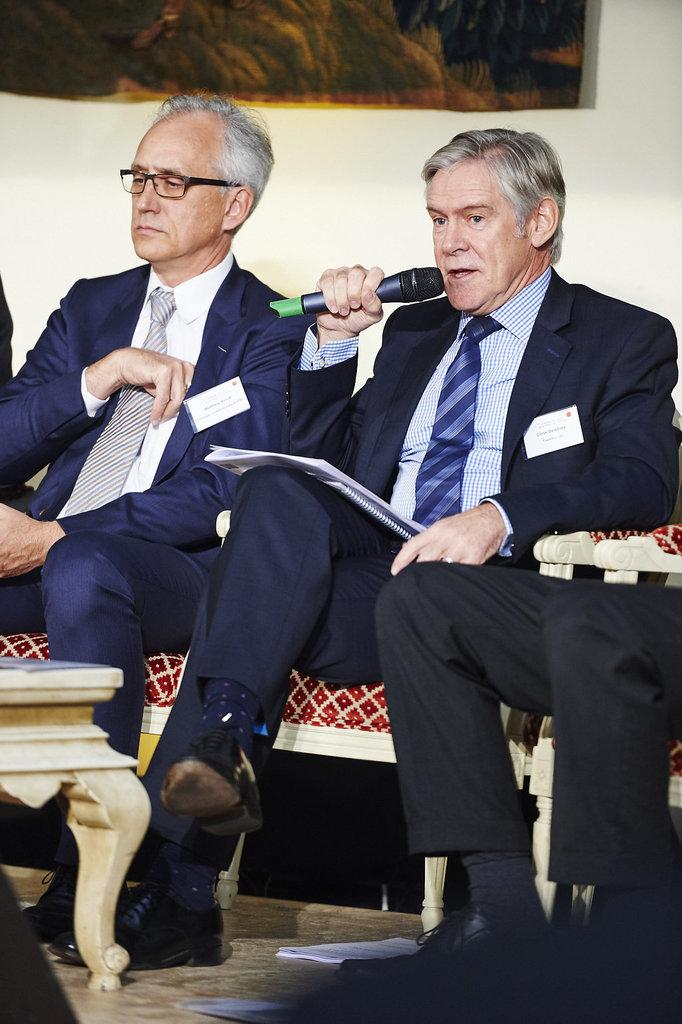What is the color of the wall in the image? The wall in the image is white. What are the people in the image doing? The people in the image are sitting on a sofa. What other furniture can be seen in the image? There is a table in the image. What type of sound can be heard coming from the earth in the image? There is no sound or reference to the earth in the image; it only features a white wall, people sitting on a sofa, and a table. 